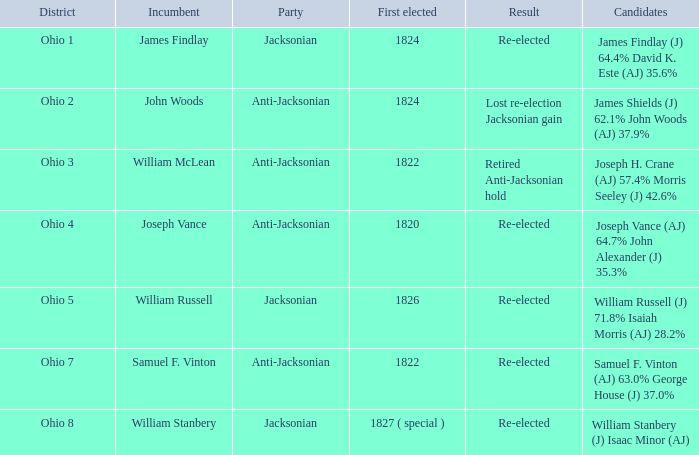What was the result for the candidate first elected in 1820? Re-elected. 